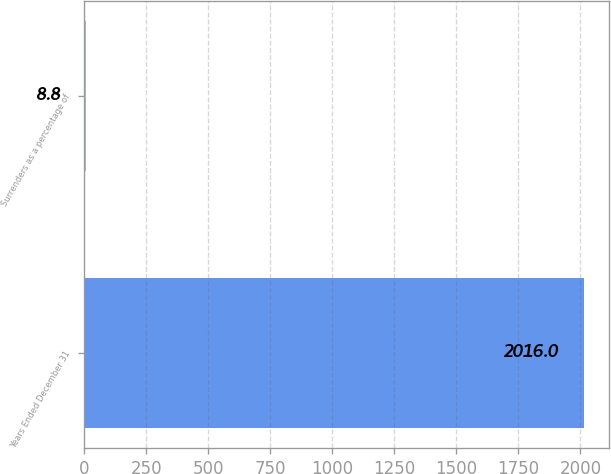<chart> <loc_0><loc_0><loc_500><loc_500><bar_chart><fcel>Years Ended December 31<fcel>Surrenders as a percentage of<nl><fcel>2016<fcel>8.8<nl></chart> 